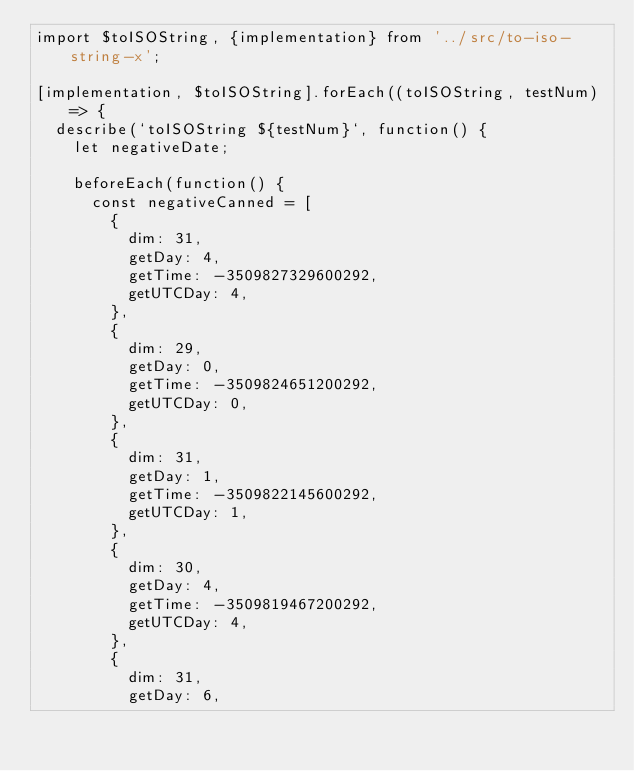<code> <loc_0><loc_0><loc_500><loc_500><_JavaScript_>import $toISOString, {implementation} from '../src/to-iso-string-x';

[implementation, $toISOString].forEach((toISOString, testNum) => {
  describe(`toISOString ${testNum}`, function() {
    let negativeDate;

    beforeEach(function() {
      const negativeCanned = [
        {
          dim: 31,
          getDay: 4,
          getTime: -3509827329600292,
          getUTCDay: 4,
        },
        {
          dim: 29,
          getDay: 0,
          getTime: -3509824651200292,
          getUTCDay: 0,
        },
        {
          dim: 31,
          getDay: 1,
          getTime: -3509822145600292,
          getUTCDay: 1,
        },
        {
          dim: 30,
          getDay: 4,
          getTime: -3509819467200292,
          getUTCDay: 4,
        },
        {
          dim: 31,
          getDay: 6,</code> 